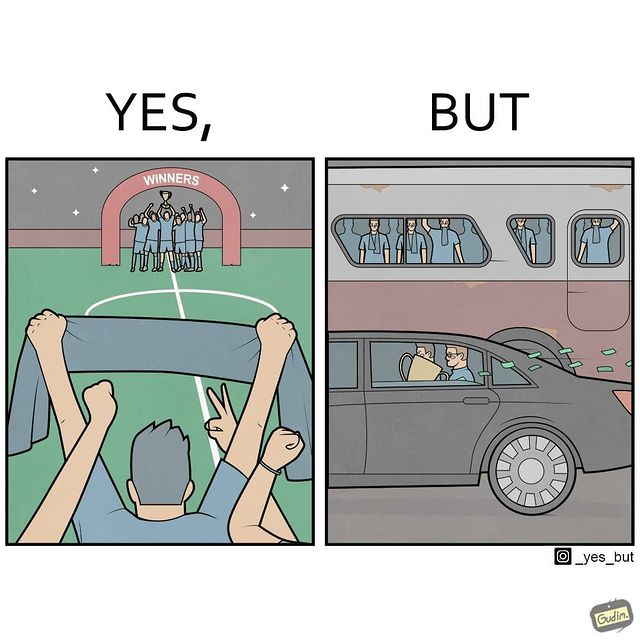What makes this image funny or satirical? The image is ironical, as a team and its are all celebrating on the ground after winning the match, but after the match, the fans are standing in the bus uncomfortably, while the players are travelling inside a carring the cup as well as the prize money, which the fans did not get a dime of. 